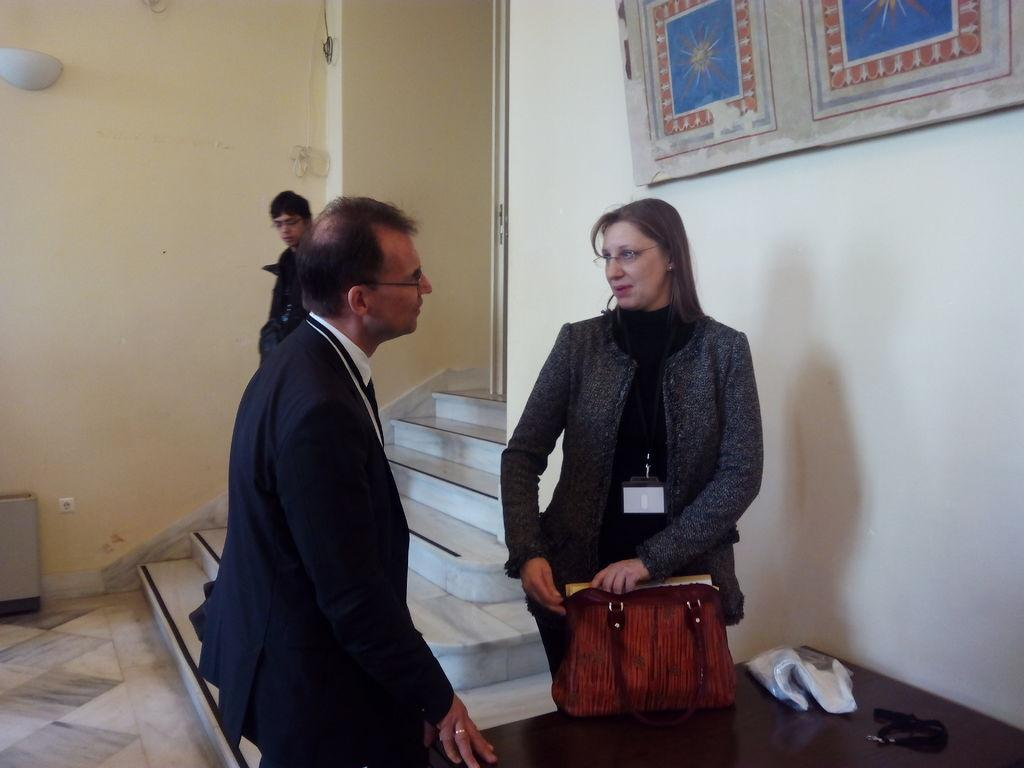How many people are in the image? There are three people in the image. What are the two persons near the table doing? The facts do not specify what the two persons near the table are doing. What object can be seen in the image besides the people and the table? There is a bag in the image. What is attached to the wall in the background? There is there a frame? Where is the third person located in the image? The third person is near the staircase. What type of soap is being used by the person near the staircase? There is no soap present in the image, and therefore no such activity can be observed. 